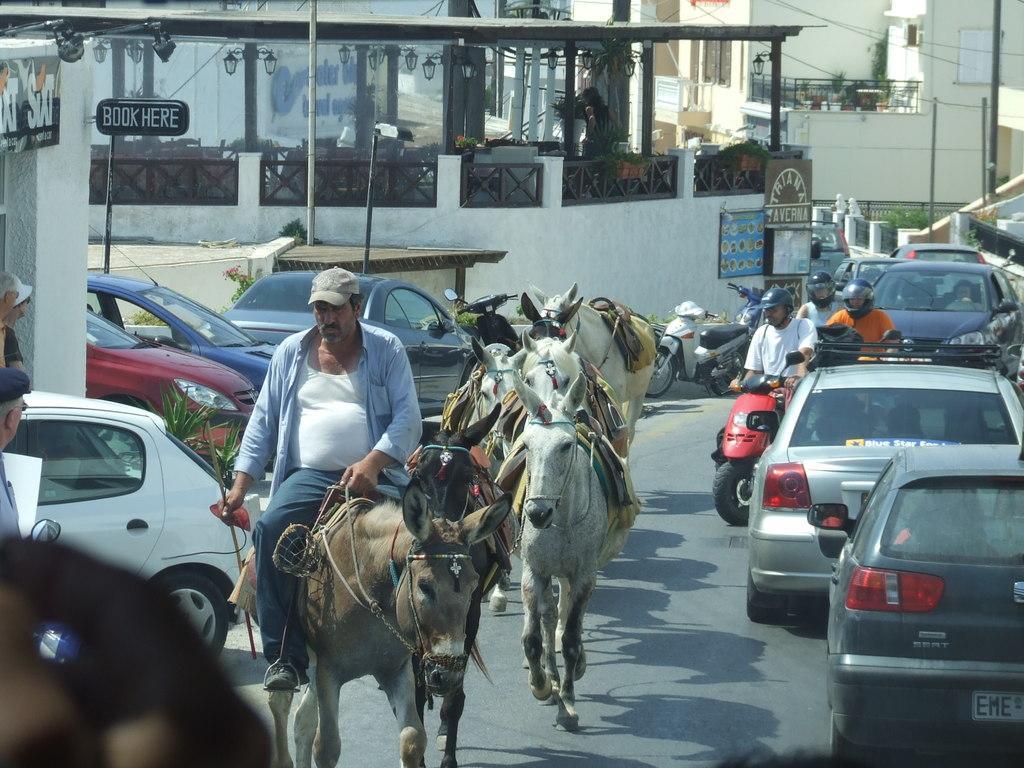Describe this image in one or two sentences. In this image we can see a person sitting on a horse and here we can see three horses beside to the man. Here we can see motor vehicles and cars on the left side and right side as well. 